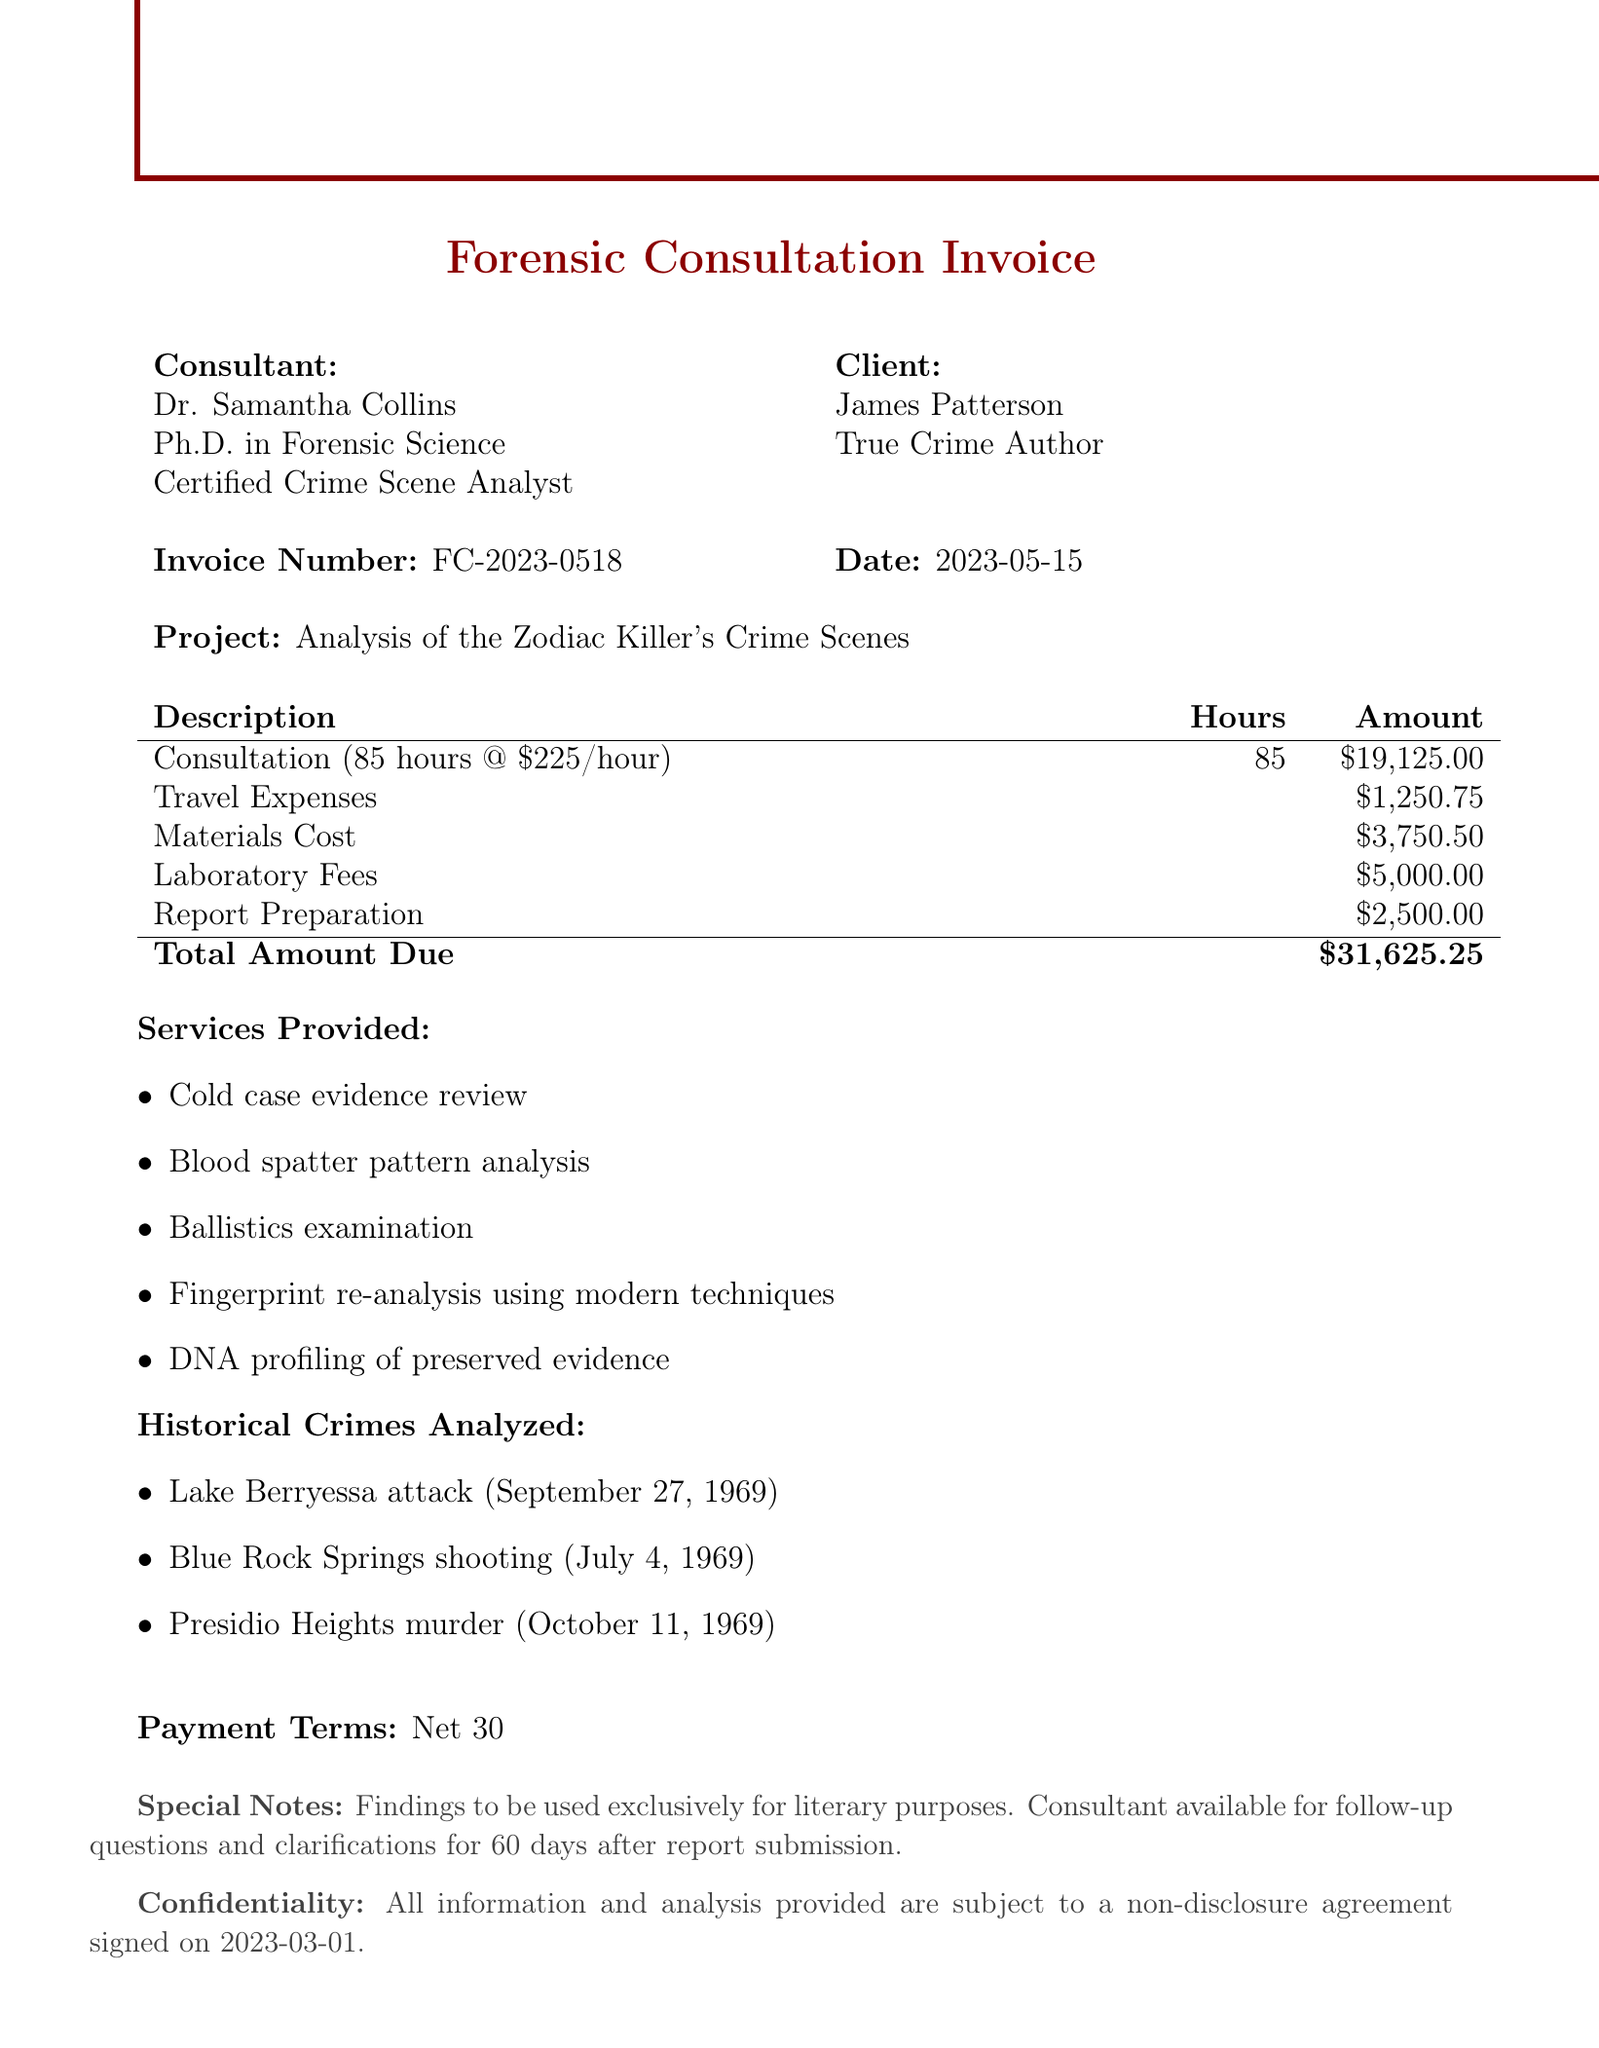What is the name of the forensic consultant? The document explicitly mentions the consultant's name as Dr. Samantha Collins.
Answer: Dr. Samantha Collins What is the total amount due on the invoice? The total amount is clearly stated in the summary section of the invoice as $31,625.25.
Answer: $31,625.25 How many hours did the forensic consultant work? The document indicates that the consultant worked a total of 85 hours.
Answer: 85 What is the project title? The title of the project is outlined in the document as "Analysis of the Zodiac Killer's Crime Scenes."
Answer: Analysis of the Zodiac Killer's Crime Scenes What is the hourly rate charged by the consultant? The document specifies that the hourly rate is $225.
Answer: $225 Which historical crimes were analyzed? The document lists three crimes including the Lake Berryessa attack, Blue Rock Springs shooting, and Presidio Heights murder.
Answer: Lake Berryessa attack, Blue Rock Springs shooting, Presidio Heights murder What are the payment terms? The payment terms are stated as "Net 30" in the invoice.
Answer: Net 30 What special notes are included in the document? The special notes regarding the findings specify they are for literary purposes and mention the consultant's availability for follow-up clarifications for 60 days.
Answer: Findings to be used exclusively for literary purposes What is the confidentiality clause about? The confidentiality clause mentions that all information and analysis are subject to a non-disclosure agreement signed on 2023-03-01.
Answer: Non-disclosure agreement signed on 2023-03-01 